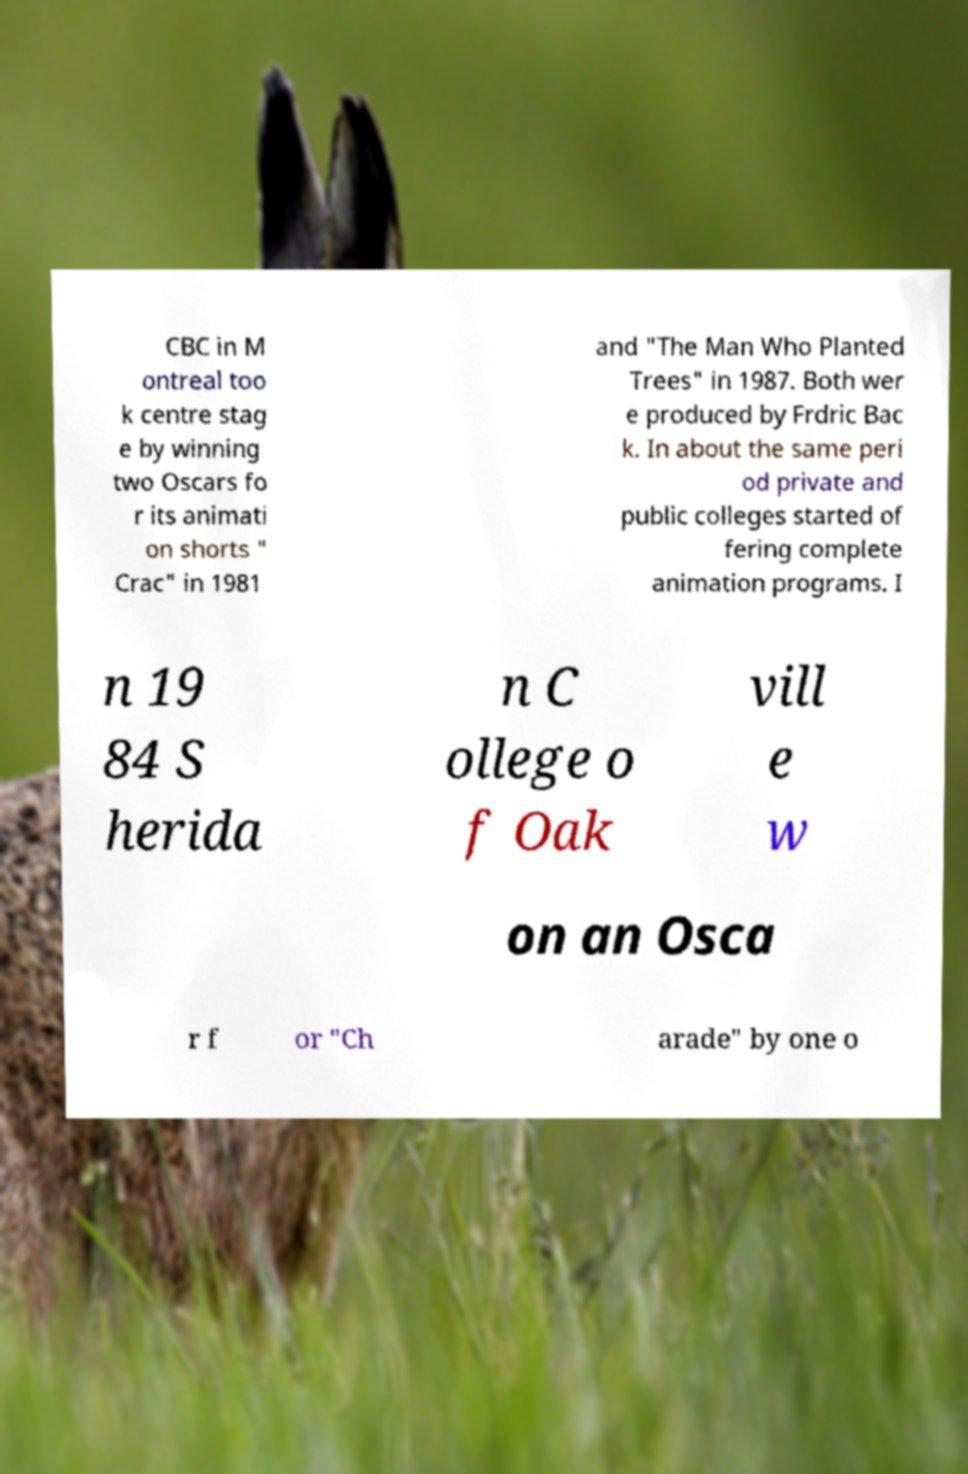Please identify and transcribe the text found in this image. CBC in M ontreal too k centre stag e by winning two Oscars fo r its animati on shorts " Crac" in 1981 and "The Man Who Planted Trees" in 1987. Both wer e produced by Frdric Bac k. In about the same peri od private and public colleges started of fering complete animation programs. I n 19 84 S herida n C ollege o f Oak vill e w on an Osca r f or "Ch arade" by one o 